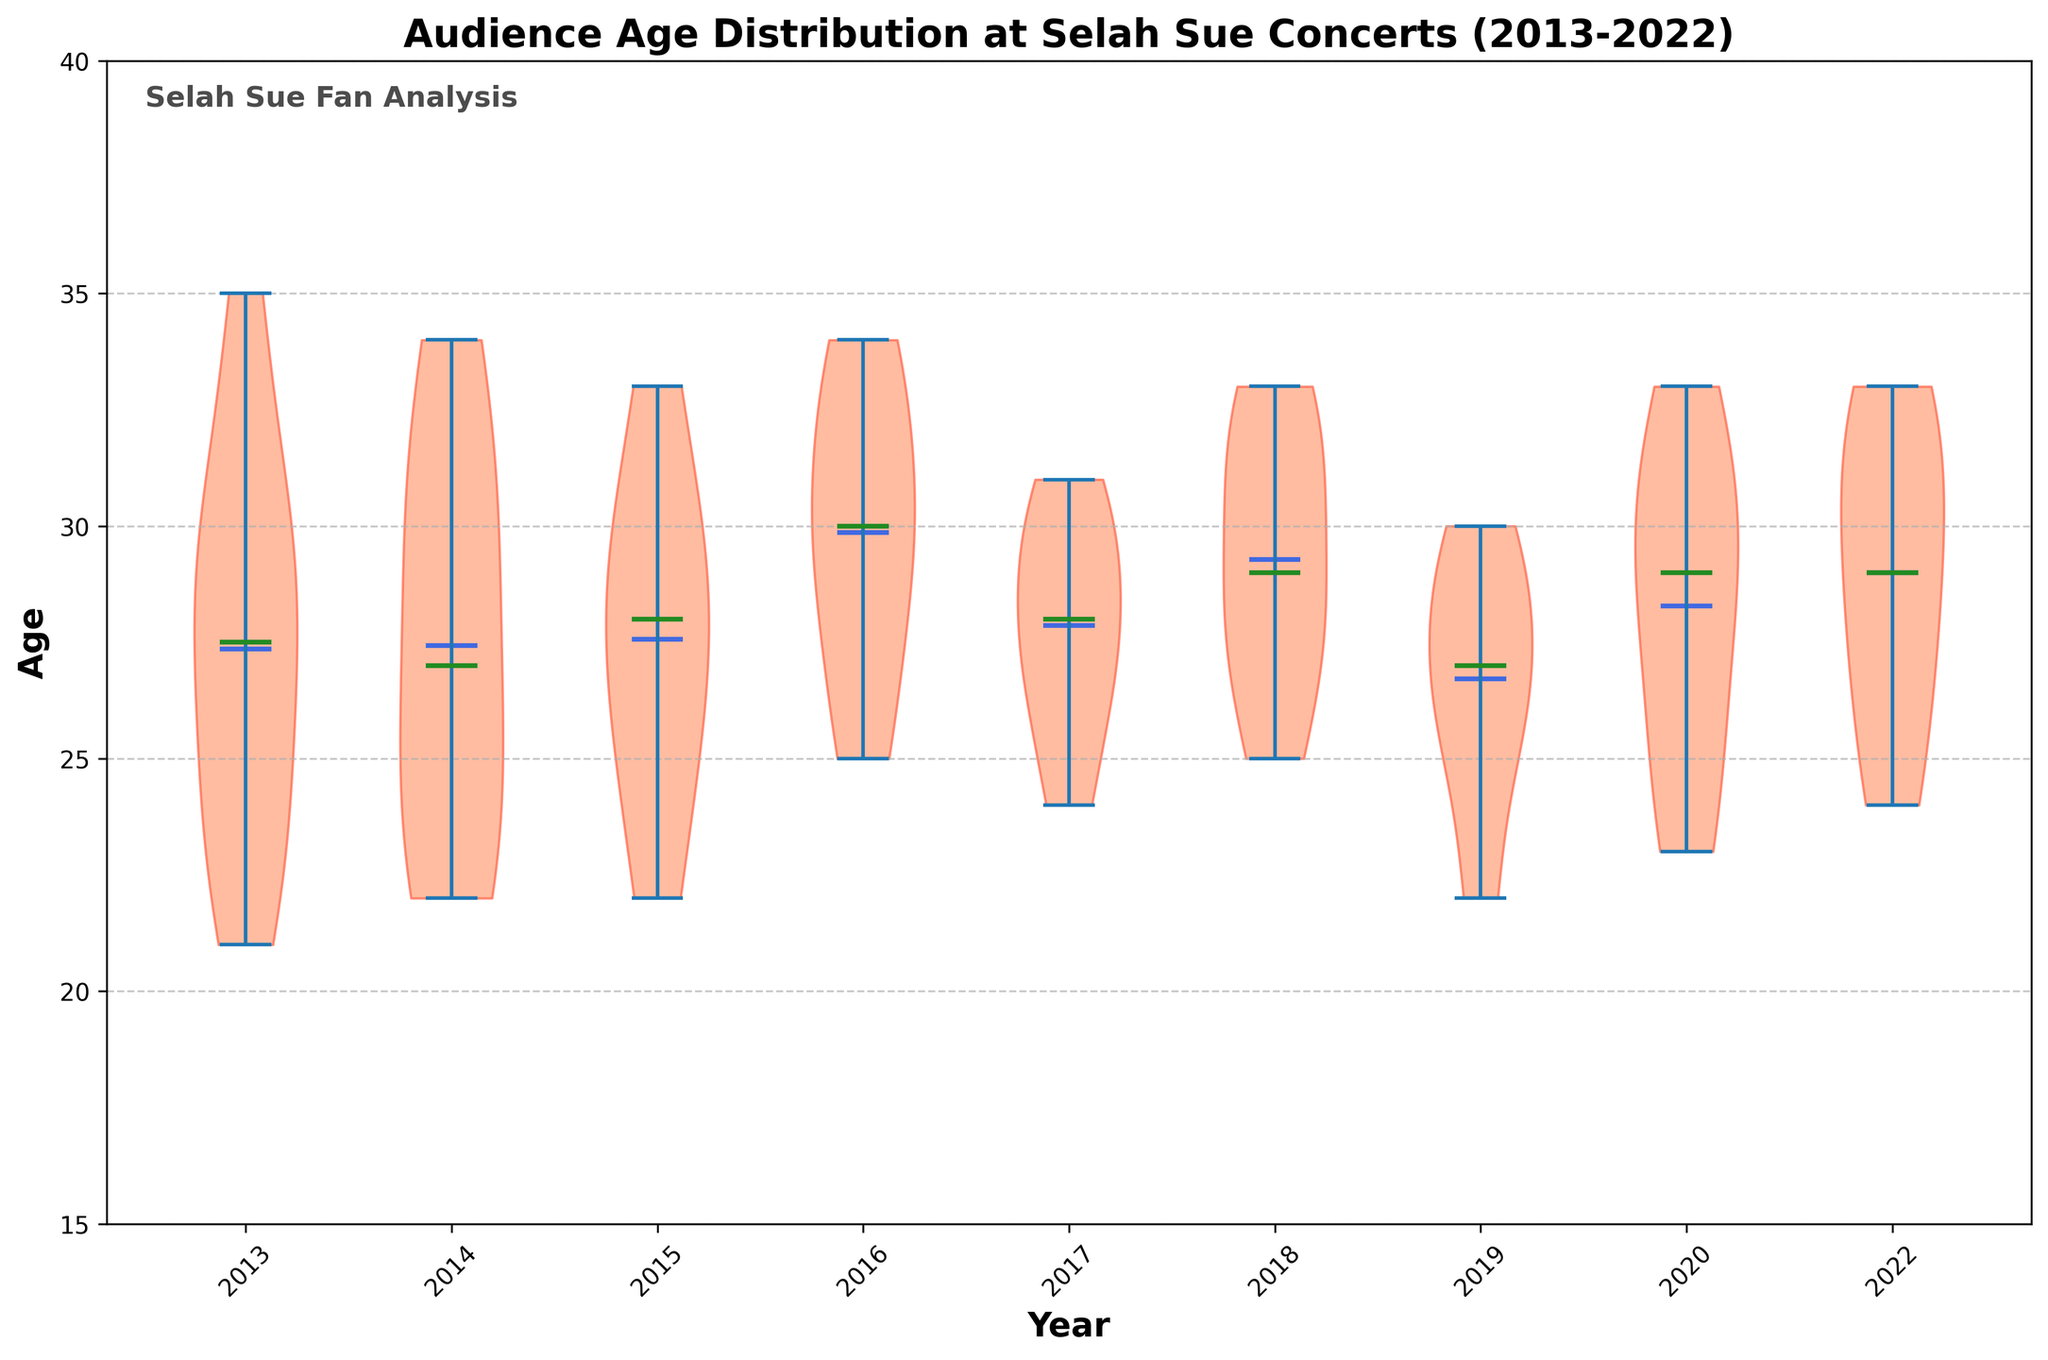What's the title of the figure? The title of the figure is usually placed at the top and is clearly visible in a larger font. In this case, it's "Audience Age Distribution at Selah Sue Concerts (2013-2022)".
Answer: Audience Age Distribution at Selah Sue Concerts (2013-2022) What are the colors of the mean and median lines in the chart? The mean lines are colored in a Royal Blue-like color, and the median lines are in a Forest Green-like color. This can be observed from the distinct lines in each violin plot.
Answer: Mean lines: Royal Blue, Median lines: Forest Green Which year showed the highest average audience age? By comparing the means, which are marked by the distinct blue lines across the violins, it appears that 2014 displayed the highest average audience age because the blue line is the highest for 2014.
Answer: 2014 Is the age distribution in 2015 wider or narrower compared to 2017? To determine this, observe the width of the violin shapes. In the figure, the violin for 2015 is wider than that for 2017, indicating a broader age distribution in 2015.
Answer: Wider Was the median age higher in 2016 or 2020? The median is indicated by the green line within each violin. By observing the heights of the green lines for these years, 2016's median age line is higher than that of 2020.
Answer: 2016 What is the general age range of the audience over the years? The y-axis displays ages from 15 to 40, and the violins generally span from around 20 to 35, showing the typical age range.
Answer: 20 to 35 How does the median age in 2013 compare to that in 2022? The green (median) lines for both years need to be compared. The median age for 2013 is slightly lower than that for 2022, judging by the heights of the green lines.
Answer: Lower in 2013 Which year had the most symmetrical age distribution? Symmetry in a violin plot is indicated by equal spread on both sides of the center line. By observing the violins, 2018 seems the most symmetrical, showing equal spread on both sides.
Answer: 2018 Was there any year when the audience age distribution was significantly different from other years? To answer this, look for any violin plot that appears significantly different in shape or spread. In this figure, 2014 stands out with a notably higher average age and possibly different distribution.
Answer: 2014 